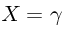Convert formula to latex. <formula><loc_0><loc_0><loc_500><loc_500>X = \gamma</formula> 